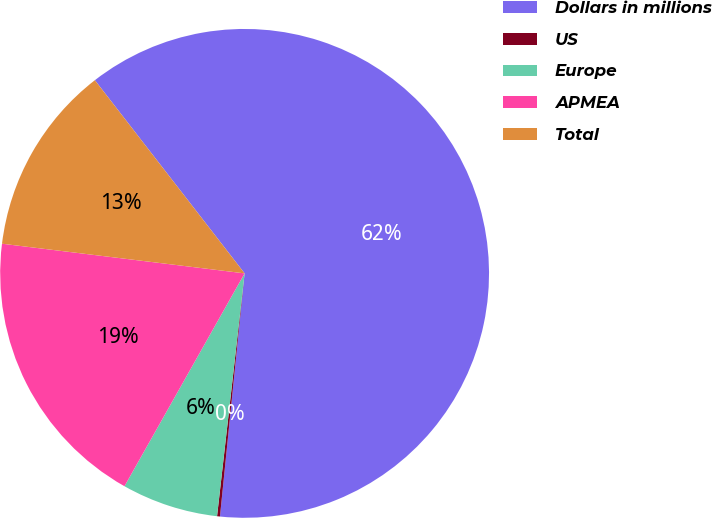<chart> <loc_0><loc_0><loc_500><loc_500><pie_chart><fcel>Dollars in millions<fcel>US<fcel>Europe<fcel>APMEA<fcel>Total<nl><fcel>62.11%<fcel>0.19%<fcel>6.38%<fcel>18.76%<fcel>12.57%<nl></chart> 